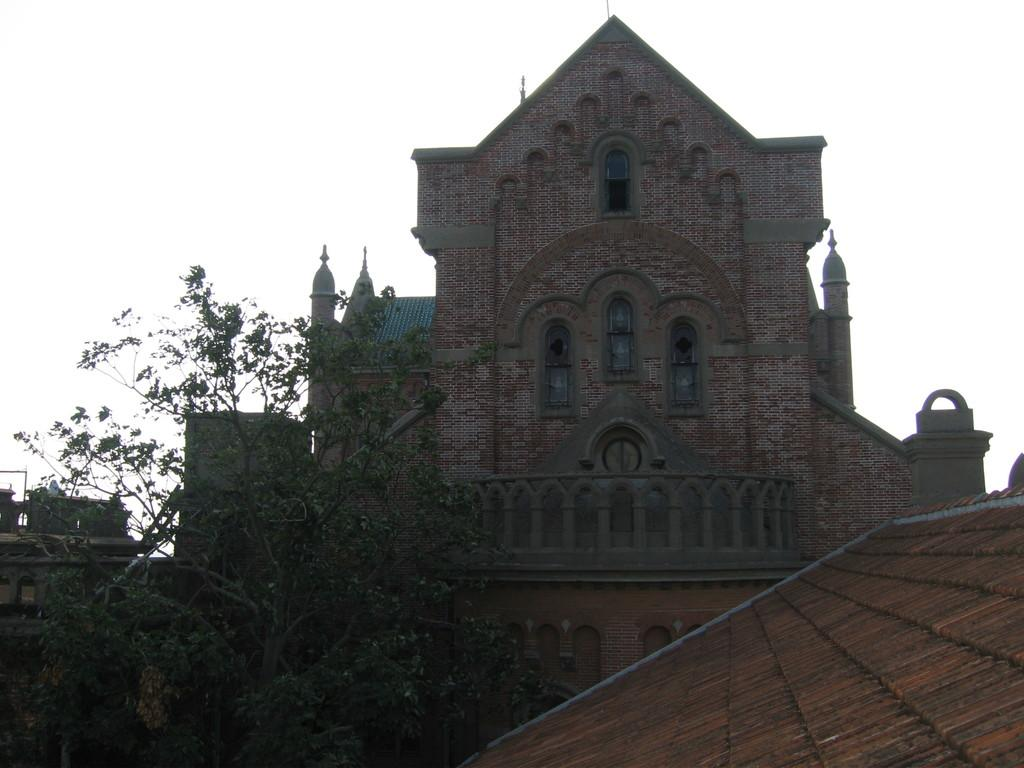What part of a building can be seen in the image? The roof of a building is visible in the image. Are there any other buildings in the image besides the one with the visible roof? Yes, there are other buildings in the image. What type of vegetation is present in the image? There is a tree in the image. What can be seen in the background of the image? The sky is visible in the background of the image. What type of agreement is being discussed by the strangers in the image? There are no strangers present in the image, and therefore no discussion or agreement can be observed. 